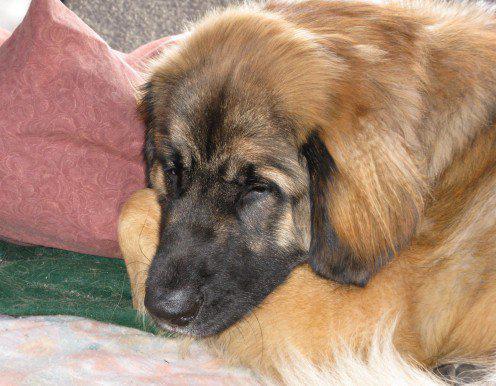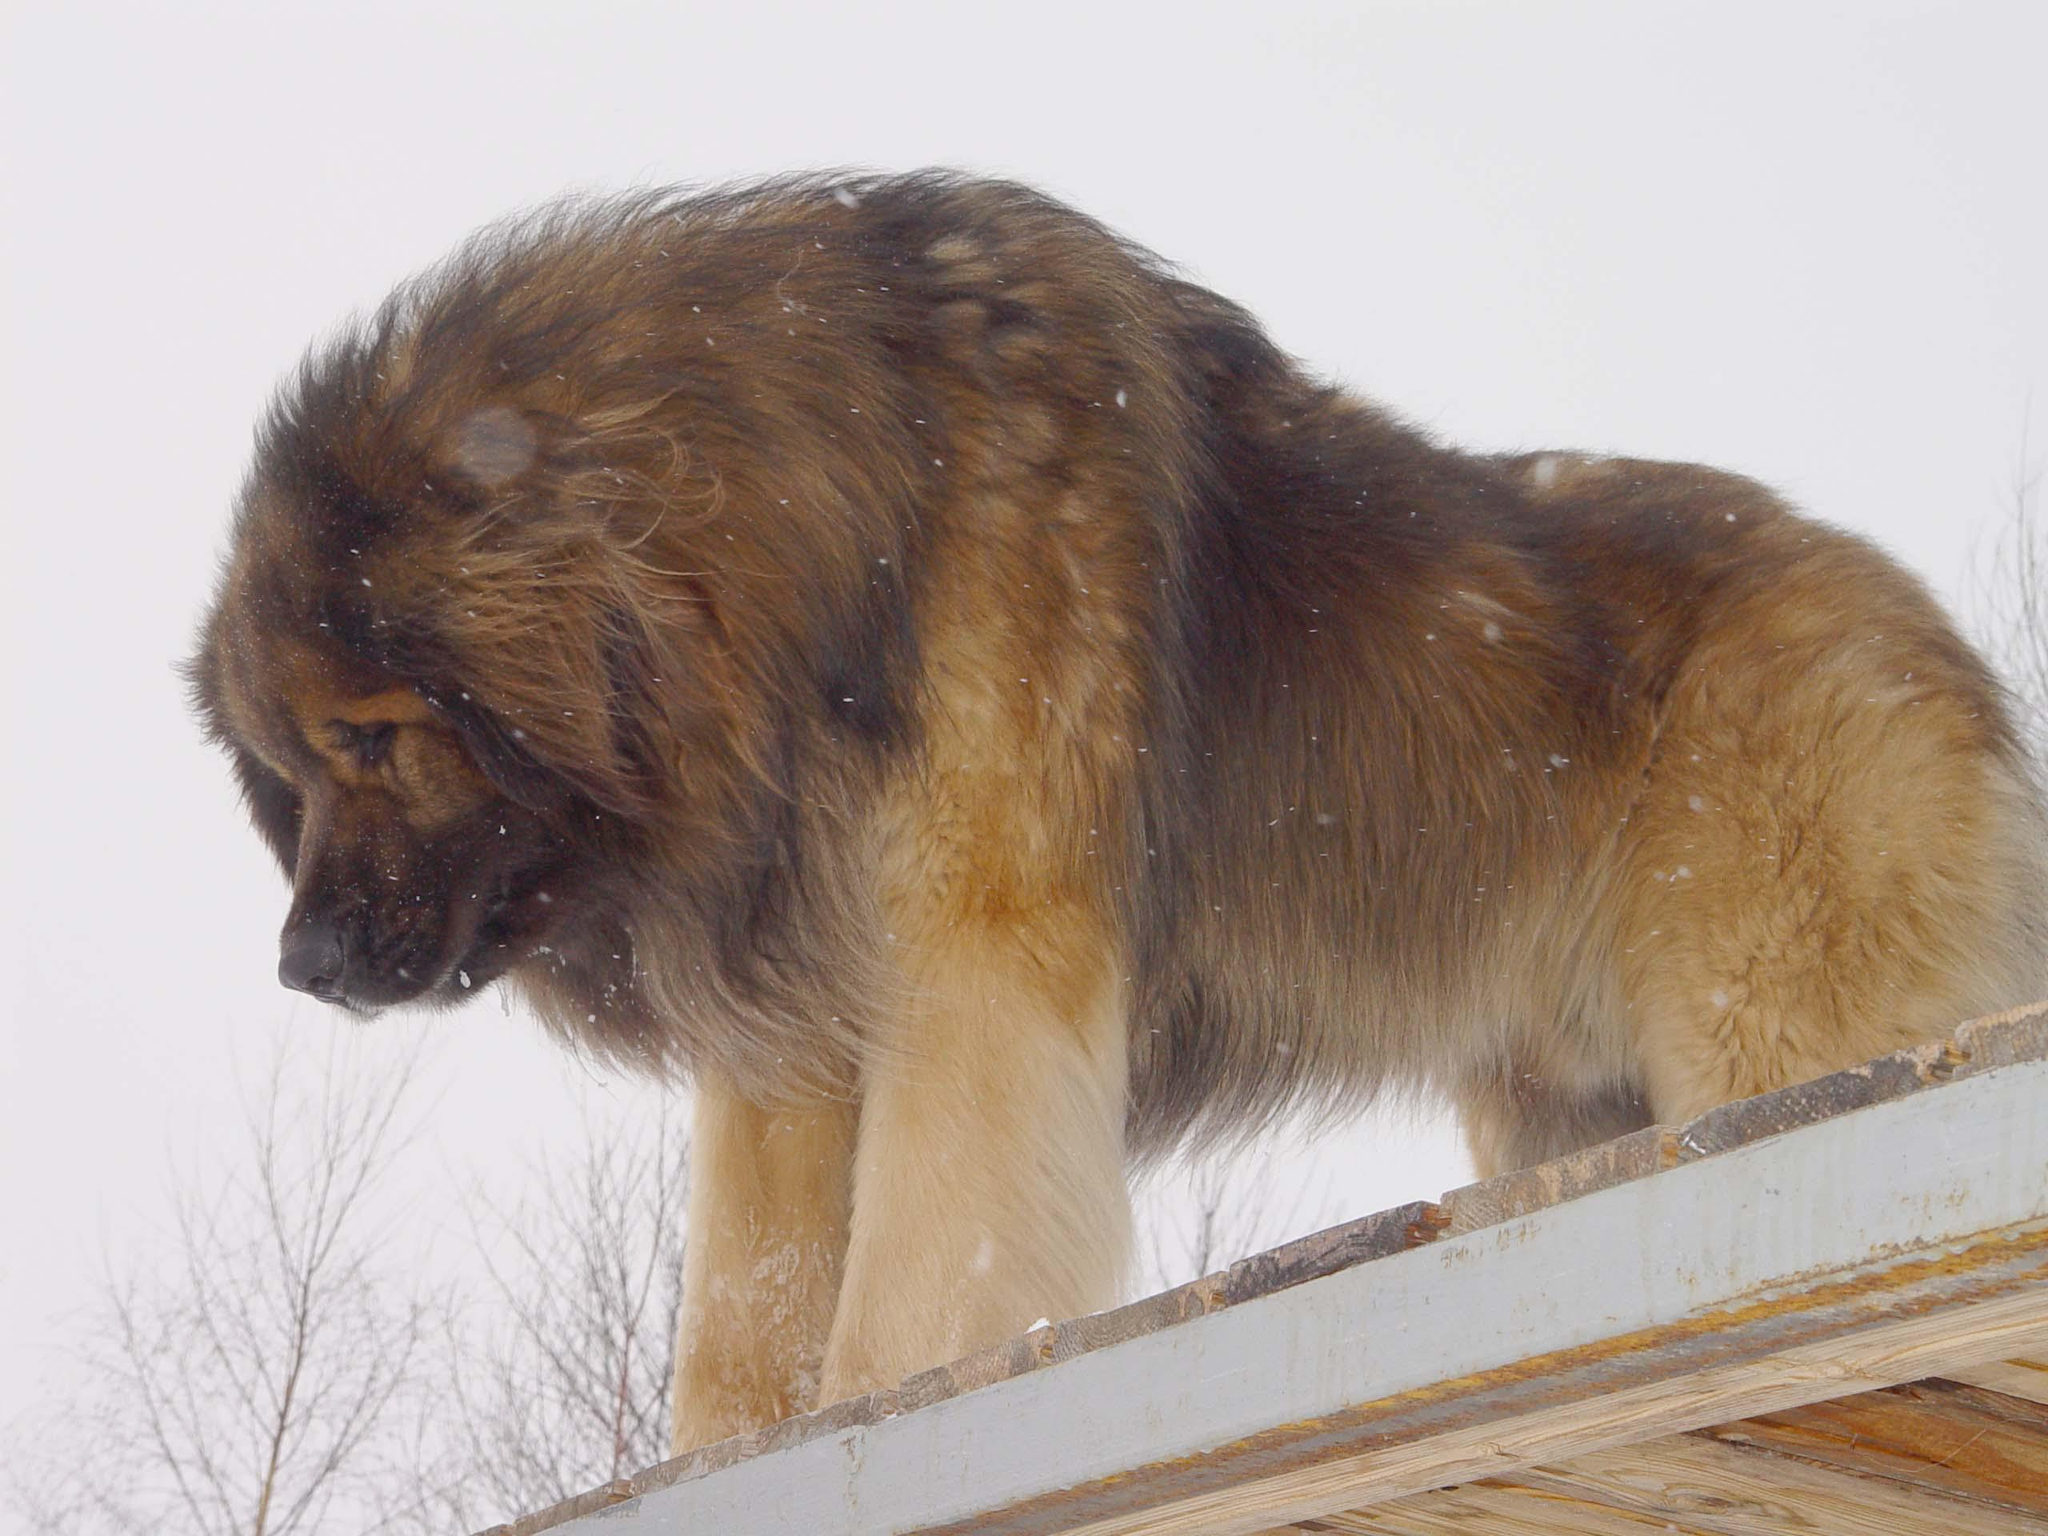The first image is the image on the left, the second image is the image on the right. Considering the images on both sides, is "A dogs" valid? Answer yes or no. No. The first image is the image on the left, the second image is the image on the right. Assess this claim about the two images: "At least one of the dogs in an image is not alone.". Correct or not? Answer yes or no. No. 